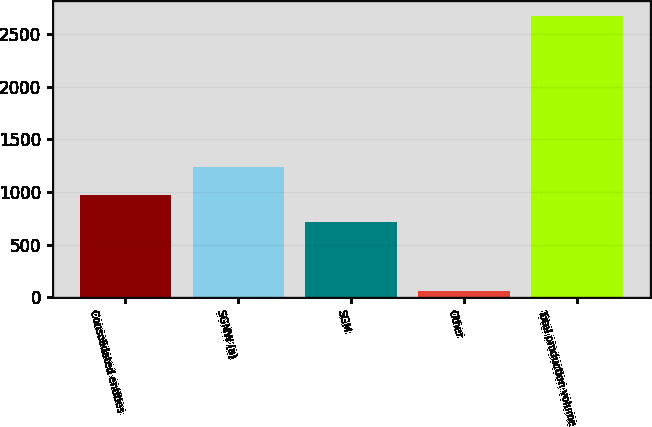<chart> <loc_0><loc_0><loc_500><loc_500><bar_chart><fcel>Consolidated entities<fcel>SGMW (a)<fcel>SGM<fcel>Other<fcel>Total production volume<nl><fcel>973.6<fcel>1235.2<fcel>712<fcel>61<fcel>2677<nl></chart> 